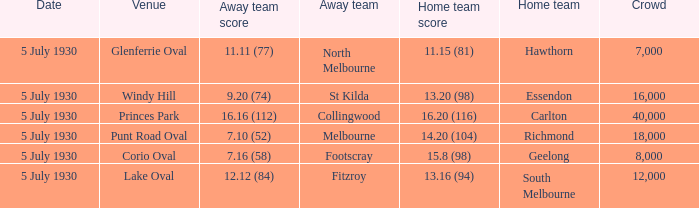What is the venue when fitzroy was the away team? Lake Oval. 